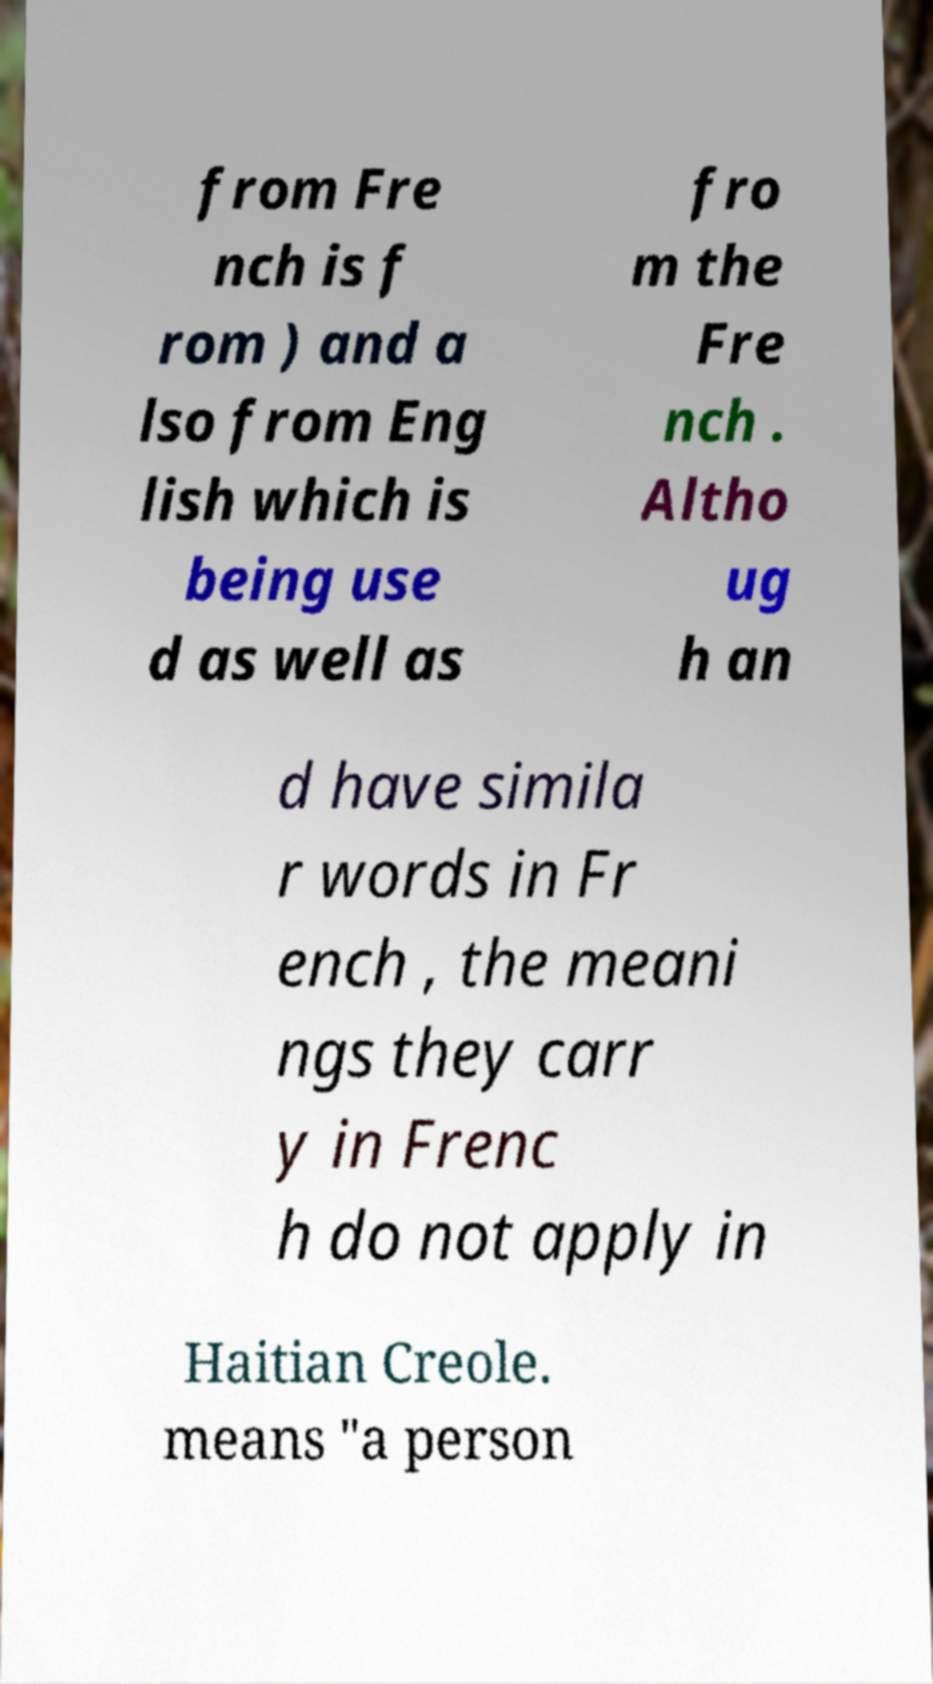Please identify and transcribe the text found in this image. from Fre nch is f rom ) and a lso from Eng lish which is being use d as well as fro m the Fre nch . Altho ug h an d have simila r words in Fr ench , the meani ngs they carr y in Frenc h do not apply in Haitian Creole. means "a person 